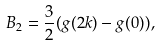<formula> <loc_0><loc_0><loc_500><loc_500>B _ { 2 } = \frac { 3 } { 2 } ( g ( 2 k ) - g ( 0 ) ) ,</formula> 